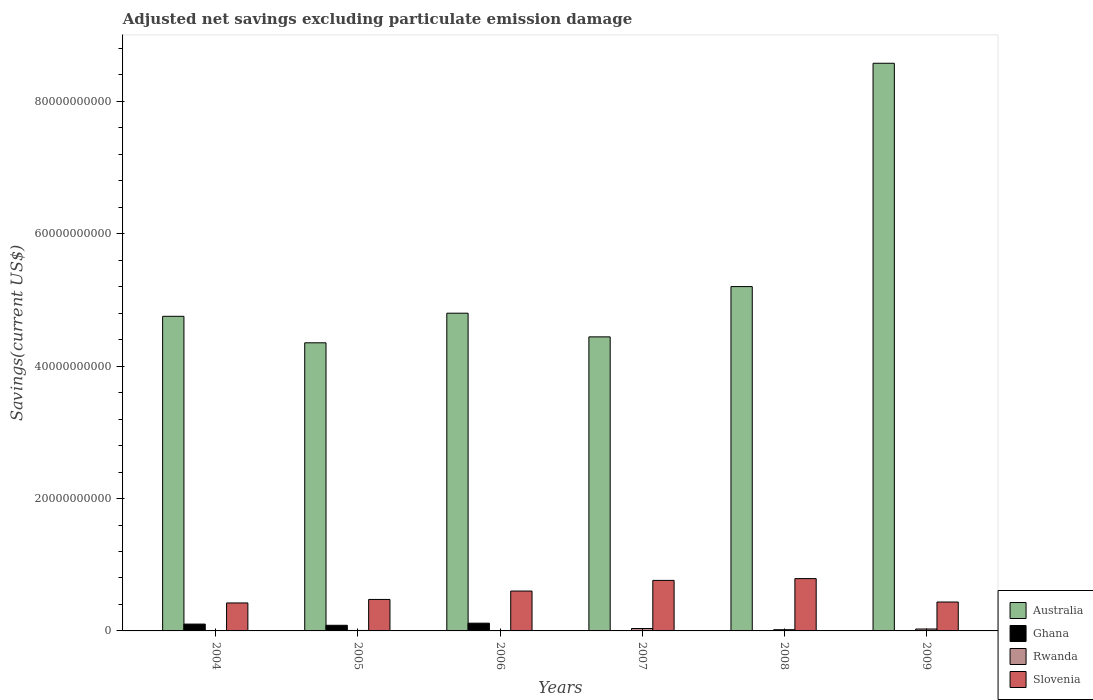How many groups of bars are there?
Ensure brevity in your answer.  6. Are the number of bars per tick equal to the number of legend labels?
Keep it short and to the point. No. Are the number of bars on each tick of the X-axis equal?
Your answer should be very brief. No. In how many cases, is the number of bars for a given year not equal to the number of legend labels?
Give a very brief answer. 2. What is the adjusted net savings in Rwanda in 2005?
Your answer should be very brief. 6.94e+07. Across all years, what is the maximum adjusted net savings in Australia?
Give a very brief answer. 8.58e+1. Across all years, what is the minimum adjusted net savings in Australia?
Ensure brevity in your answer.  4.35e+1. What is the total adjusted net savings in Slovenia in the graph?
Give a very brief answer. 3.49e+1. What is the difference between the adjusted net savings in Ghana in 2004 and that in 2005?
Your answer should be very brief. 1.82e+08. What is the difference between the adjusted net savings in Slovenia in 2009 and the adjusted net savings in Ghana in 2006?
Your response must be concise. 3.20e+09. What is the average adjusted net savings in Slovenia per year?
Ensure brevity in your answer.  5.82e+09. In the year 2007, what is the difference between the adjusted net savings in Rwanda and adjusted net savings in Slovenia?
Give a very brief answer. -7.27e+09. What is the ratio of the adjusted net savings in Ghana in 2005 to that in 2009?
Provide a short and direct response. 362.39. Is the adjusted net savings in Slovenia in 2007 less than that in 2008?
Ensure brevity in your answer.  Yes. Is the difference between the adjusted net savings in Rwanda in 2006 and 2007 greater than the difference between the adjusted net savings in Slovenia in 2006 and 2007?
Provide a short and direct response. Yes. What is the difference between the highest and the second highest adjusted net savings in Ghana?
Offer a very short reply. 1.38e+08. What is the difference between the highest and the lowest adjusted net savings in Australia?
Make the answer very short. 4.22e+1. Is it the case that in every year, the sum of the adjusted net savings in Australia and adjusted net savings in Rwanda is greater than the adjusted net savings in Slovenia?
Your answer should be very brief. Yes. Are the values on the major ticks of Y-axis written in scientific E-notation?
Your response must be concise. No. Does the graph contain grids?
Provide a short and direct response. No. Where does the legend appear in the graph?
Your response must be concise. Bottom right. How are the legend labels stacked?
Offer a terse response. Vertical. What is the title of the graph?
Provide a short and direct response. Adjusted net savings excluding particulate emission damage. What is the label or title of the X-axis?
Keep it short and to the point. Years. What is the label or title of the Y-axis?
Provide a short and direct response. Savings(current US$). What is the Savings(current US$) of Australia in 2004?
Keep it short and to the point. 4.75e+1. What is the Savings(current US$) of Ghana in 2004?
Provide a short and direct response. 1.03e+09. What is the Savings(current US$) of Rwanda in 2004?
Ensure brevity in your answer.  2.06e+07. What is the Savings(current US$) in Slovenia in 2004?
Your response must be concise. 4.23e+09. What is the Savings(current US$) in Australia in 2005?
Ensure brevity in your answer.  4.35e+1. What is the Savings(current US$) of Ghana in 2005?
Your response must be concise. 8.50e+08. What is the Savings(current US$) of Rwanda in 2005?
Ensure brevity in your answer.  6.94e+07. What is the Savings(current US$) of Slovenia in 2005?
Provide a succinct answer. 4.76e+09. What is the Savings(current US$) in Australia in 2006?
Your answer should be very brief. 4.80e+1. What is the Savings(current US$) of Ghana in 2006?
Your response must be concise. 1.17e+09. What is the Savings(current US$) of Rwanda in 2006?
Give a very brief answer. 5.25e+07. What is the Savings(current US$) in Slovenia in 2006?
Your answer should be compact. 6.02e+09. What is the Savings(current US$) in Australia in 2007?
Offer a very short reply. 4.44e+1. What is the Savings(current US$) of Rwanda in 2007?
Offer a terse response. 3.66e+08. What is the Savings(current US$) in Slovenia in 2007?
Your answer should be compact. 7.63e+09. What is the Savings(current US$) of Australia in 2008?
Your answer should be very brief. 5.20e+1. What is the Savings(current US$) of Ghana in 2008?
Ensure brevity in your answer.  0. What is the Savings(current US$) of Rwanda in 2008?
Your answer should be very brief. 1.84e+08. What is the Savings(current US$) of Slovenia in 2008?
Ensure brevity in your answer.  7.90e+09. What is the Savings(current US$) in Australia in 2009?
Give a very brief answer. 8.58e+1. What is the Savings(current US$) of Ghana in 2009?
Give a very brief answer. 2.35e+06. What is the Savings(current US$) of Rwanda in 2009?
Make the answer very short. 2.89e+08. What is the Savings(current US$) of Slovenia in 2009?
Your answer should be very brief. 4.37e+09. Across all years, what is the maximum Savings(current US$) in Australia?
Keep it short and to the point. 8.58e+1. Across all years, what is the maximum Savings(current US$) in Ghana?
Your answer should be very brief. 1.17e+09. Across all years, what is the maximum Savings(current US$) in Rwanda?
Offer a very short reply. 3.66e+08. Across all years, what is the maximum Savings(current US$) in Slovenia?
Keep it short and to the point. 7.90e+09. Across all years, what is the minimum Savings(current US$) of Australia?
Offer a terse response. 4.35e+1. Across all years, what is the minimum Savings(current US$) in Ghana?
Keep it short and to the point. 0. Across all years, what is the minimum Savings(current US$) in Rwanda?
Give a very brief answer. 2.06e+07. Across all years, what is the minimum Savings(current US$) of Slovenia?
Ensure brevity in your answer.  4.23e+09. What is the total Savings(current US$) in Australia in the graph?
Make the answer very short. 3.21e+11. What is the total Savings(current US$) of Ghana in the graph?
Your answer should be compact. 3.05e+09. What is the total Savings(current US$) in Rwanda in the graph?
Ensure brevity in your answer.  9.81e+08. What is the total Savings(current US$) in Slovenia in the graph?
Give a very brief answer. 3.49e+1. What is the difference between the Savings(current US$) of Australia in 2004 and that in 2005?
Your response must be concise. 4.00e+09. What is the difference between the Savings(current US$) in Ghana in 2004 and that in 2005?
Ensure brevity in your answer.  1.82e+08. What is the difference between the Savings(current US$) of Rwanda in 2004 and that in 2005?
Your answer should be compact. -4.88e+07. What is the difference between the Savings(current US$) of Slovenia in 2004 and that in 2005?
Ensure brevity in your answer.  -5.29e+08. What is the difference between the Savings(current US$) in Australia in 2004 and that in 2006?
Ensure brevity in your answer.  -4.69e+08. What is the difference between the Savings(current US$) of Ghana in 2004 and that in 2006?
Offer a very short reply. -1.38e+08. What is the difference between the Savings(current US$) in Rwanda in 2004 and that in 2006?
Provide a succinct answer. -3.19e+07. What is the difference between the Savings(current US$) in Slovenia in 2004 and that in 2006?
Offer a terse response. -1.80e+09. What is the difference between the Savings(current US$) of Australia in 2004 and that in 2007?
Your response must be concise. 3.11e+09. What is the difference between the Savings(current US$) in Rwanda in 2004 and that in 2007?
Offer a very short reply. -3.45e+08. What is the difference between the Savings(current US$) of Slovenia in 2004 and that in 2007?
Provide a succinct answer. -3.41e+09. What is the difference between the Savings(current US$) of Australia in 2004 and that in 2008?
Offer a very short reply. -4.49e+09. What is the difference between the Savings(current US$) of Rwanda in 2004 and that in 2008?
Offer a very short reply. -1.63e+08. What is the difference between the Savings(current US$) in Slovenia in 2004 and that in 2008?
Give a very brief answer. -3.68e+09. What is the difference between the Savings(current US$) in Australia in 2004 and that in 2009?
Offer a terse response. -3.82e+1. What is the difference between the Savings(current US$) of Ghana in 2004 and that in 2009?
Make the answer very short. 1.03e+09. What is the difference between the Savings(current US$) in Rwanda in 2004 and that in 2009?
Make the answer very short. -2.68e+08. What is the difference between the Savings(current US$) in Slovenia in 2004 and that in 2009?
Your answer should be compact. -1.42e+08. What is the difference between the Savings(current US$) in Australia in 2005 and that in 2006?
Offer a very short reply. -4.47e+09. What is the difference between the Savings(current US$) in Ghana in 2005 and that in 2006?
Offer a very short reply. -3.20e+08. What is the difference between the Savings(current US$) in Rwanda in 2005 and that in 2006?
Provide a succinct answer. 1.68e+07. What is the difference between the Savings(current US$) of Slovenia in 2005 and that in 2006?
Offer a terse response. -1.27e+09. What is the difference between the Savings(current US$) in Australia in 2005 and that in 2007?
Your response must be concise. -8.97e+08. What is the difference between the Savings(current US$) in Rwanda in 2005 and that in 2007?
Offer a very short reply. -2.96e+08. What is the difference between the Savings(current US$) of Slovenia in 2005 and that in 2007?
Your answer should be very brief. -2.88e+09. What is the difference between the Savings(current US$) of Australia in 2005 and that in 2008?
Offer a very short reply. -8.49e+09. What is the difference between the Savings(current US$) in Rwanda in 2005 and that in 2008?
Provide a short and direct response. -1.15e+08. What is the difference between the Savings(current US$) in Slovenia in 2005 and that in 2008?
Offer a terse response. -3.15e+09. What is the difference between the Savings(current US$) in Australia in 2005 and that in 2009?
Provide a short and direct response. -4.22e+1. What is the difference between the Savings(current US$) of Ghana in 2005 and that in 2009?
Give a very brief answer. 8.48e+08. What is the difference between the Savings(current US$) in Rwanda in 2005 and that in 2009?
Provide a succinct answer. -2.19e+08. What is the difference between the Savings(current US$) of Slovenia in 2005 and that in 2009?
Offer a very short reply. 3.87e+08. What is the difference between the Savings(current US$) of Australia in 2006 and that in 2007?
Give a very brief answer. 3.58e+09. What is the difference between the Savings(current US$) in Rwanda in 2006 and that in 2007?
Offer a terse response. -3.13e+08. What is the difference between the Savings(current US$) in Slovenia in 2006 and that in 2007?
Your response must be concise. -1.61e+09. What is the difference between the Savings(current US$) of Australia in 2006 and that in 2008?
Provide a short and direct response. -4.02e+09. What is the difference between the Savings(current US$) of Rwanda in 2006 and that in 2008?
Give a very brief answer. -1.32e+08. What is the difference between the Savings(current US$) in Slovenia in 2006 and that in 2008?
Provide a short and direct response. -1.88e+09. What is the difference between the Savings(current US$) in Australia in 2006 and that in 2009?
Provide a succinct answer. -3.78e+1. What is the difference between the Savings(current US$) in Ghana in 2006 and that in 2009?
Ensure brevity in your answer.  1.17e+09. What is the difference between the Savings(current US$) in Rwanda in 2006 and that in 2009?
Your answer should be compact. -2.36e+08. What is the difference between the Savings(current US$) in Slovenia in 2006 and that in 2009?
Offer a very short reply. 1.65e+09. What is the difference between the Savings(current US$) in Australia in 2007 and that in 2008?
Offer a very short reply. -7.60e+09. What is the difference between the Savings(current US$) of Rwanda in 2007 and that in 2008?
Make the answer very short. 1.82e+08. What is the difference between the Savings(current US$) in Slovenia in 2007 and that in 2008?
Offer a very short reply. -2.70e+08. What is the difference between the Savings(current US$) in Australia in 2007 and that in 2009?
Your answer should be very brief. -4.13e+1. What is the difference between the Savings(current US$) in Rwanda in 2007 and that in 2009?
Your answer should be very brief. 7.70e+07. What is the difference between the Savings(current US$) in Slovenia in 2007 and that in 2009?
Give a very brief answer. 3.26e+09. What is the difference between the Savings(current US$) in Australia in 2008 and that in 2009?
Your response must be concise. -3.37e+1. What is the difference between the Savings(current US$) in Rwanda in 2008 and that in 2009?
Your response must be concise. -1.05e+08. What is the difference between the Savings(current US$) in Slovenia in 2008 and that in 2009?
Your response must be concise. 3.53e+09. What is the difference between the Savings(current US$) of Australia in 2004 and the Savings(current US$) of Ghana in 2005?
Your response must be concise. 4.67e+1. What is the difference between the Savings(current US$) of Australia in 2004 and the Savings(current US$) of Rwanda in 2005?
Your response must be concise. 4.75e+1. What is the difference between the Savings(current US$) in Australia in 2004 and the Savings(current US$) in Slovenia in 2005?
Provide a short and direct response. 4.28e+1. What is the difference between the Savings(current US$) in Ghana in 2004 and the Savings(current US$) in Rwanda in 2005?
Provide a short and direct response. 9.62e+08. What is the difference between the Savings(current US$) of Ghana in 2004 and the Savings(current US$) of Slovenia in 2005?
Give a very brief answer. -3.72e+09. What is the difference between the Savings(current US$) of Rwanda in 2004 and the Savings(current US$) of Slovenia in 2005?
Offer a very short reply. -4.74e+09. What is the difference between the Savings(current US$) of Australia in 2004 and the Savings(current US$) of Ghana in 2006?
Your response must be concise. 4.64e+1. What is the difference between the Savings(current US$) of Australia in 2004 and the Savings(current US$) of Rwanda in 2006?
Your answer should be compact. 4.75e+1. What is the difference between the Savings(current US$) of Australia in 2004 and the Savings(current US$) of Slovenia in 2006?
Offer a very short reply. 4.15e+1. What is the difference between the Savings(current US$) in Ghana in 2004 and the Savings(current US$) in Rwanda in 2006?
Give a very brief answer. 9.79e+08. What is the difference between the Savings(current US$) in Ghana in 2004 and the Savings(current US$) in Slovenia in 2006?
Your response must be concise. -4.99e+09. What is the difference between the Savings(current US$) in Rwanda in 2004 and the Savings(current US$) in Slovenia in 2006?
Keep it short and to the point. -6.00e+09. What is the difference between the Savings(current US$) in Australia in 2004 and the Savings(current US$) in Rwanda in 2007?
Make the answer very short. 4.72e+1. What is the difference between the Savings(current US$) in Australia in 2004 and the Savings(current US$) in Slovenia in 2007?
Ensure brevity in your answer.  3.99e+1. What is the difference between the Savings(current US$) of Ghana in 2004 and the Savings(current US$) of Rwanda in 2007?
Your answer should be compact. 6.66e+08. What is the difference between the Savings(current US$) in Ghana in 2004 and the Savings(current US$) in Slovenia in 2007?
Provide a short and direct response. -6.60e+09. What is the difference between the Savings(current US$) of Rwanda in 2004 and the Savings(current US$) of Slovenia in 2007?
Give a very brief answer. -7.61e+09. What is the difference between the Savings(current US$) of Australia in 2004 and the Savings(current US$) of Rwanda in 2008?
Offer a terse response. 4.73e+1. What is the difference between the Savings(current US$) in Australia in 2004 and the Savings(current US$) in Slovenia in 2008?
Give a very brief answer. 3.96e+1. What is the difference between the Savings(current US$) of Ghana in 2004 and the Savings(current US$) of Rwanda in 2008?
Offer a very short reply. 8.48e+08. What is the difference between the Savings(current US$) of Ghana in 2004 and the Savings(current US$) of Slovenia in 2008?
Keep it short and to the point. -6.87e+09. What is the difference between the Savings(current US$) of Rwanda in 2004 and the Savings(current US$) of Slovenia in 2008?
Your answer should be very brief. -7.88e+09. What is the difference between the Savings(current US$) of Australia in 2004 and the Savings(current US$) of Ghana in 2009?
Ensure brevity in your answer.  4.75e+1. What is the difference between the Savings(current US$) in Australia in 2004 and the Savings(current US$) in Rwanda in 2009?
Provide a succinct answer. 4.72e+1. What is the difference between the Savings(current US$) in Australia in 2004 and the Savings(current US$) in Slovenia in 2009?
Give a very brief answer. 4.32e+1. What is the difference between the Savings(current US$) in Ghana in 2004 and the Savings(current US$) in Rwanda in 2009?
Offer a terse response. 7.43e+08. What is the difference between the Savings(current US$) in Ghana in 2004 and the Savings(current US$) in Slovenia in 2009?
Ensure brevity in your answer.  -3.34e+09. What is the difference between the Savings(current US$) of Rwanda in 2004 and the Savings(current US$) of Slovenia in 2009?
Keep it short and to the point. -4.35e+09. What is the difference between the Savings(current US$) of Australia in 2005 and the Savings(current US$) of Ghana in 2006?
Your answer should be compact. 4.24e+1. What is the difference between the Savings(current US$) of Australia in 2005 and the Savings(current US$) of Rwanda in 2006?
Give a very brief answer. 4.35e+1. What is the difference between the Savings(current US$) in Australia in 2005 and the Savings(current US$) in Slovenia in 2006?
Offer a terse response. 3.75e+1. What is the difference between the Savings(current US$) of Ghana in 2005 and the Savings(current US$) of Rwanda in 2006?
Give a very brief answer. 7.97e+08. What is the difference between the Savings(current US$) of Ghana in 2005 and the Savings(current US$) of Slovenia in 2006?
Offer a very short reply. -5.17e+09. What is the difference between the Savings(current US$) of Rwanda in 2005 and the Savings(current US$) of Slovenia in 2006?
Offer a very short reply. -5.95e+09. What is the difference between the Savings(current US$) in Australia in 2005 and the Savings(current US$) in Rwanda in 2007?
Offer a very short reply. 4.32e+1. What is the difference between the Savings(current US$) in Australia in 2005 and the Savings(current US$) in Slovenia in 2007?
Give a very brief answer. 3.59e+1. What is the difference between the Savings(current US$) of Ghana in 2005 and the Savings(current US$) of Rwanda in 2007?
Offer a very short reply. 4.84e+08. What is the difference between the Savings(current US$) in Ghana in 2005 and the Savings(current US$) in Slovenia in 2007?
Give a very brief answer. -6.78e+09. What is the difference between the Savings(current US$) in Rwanda in 2005 and the Savings(current US$) in Slovenia in 2007?
Offer a terse response. -7.56e+09. What is the difference between the Savings(current US$) in Australia in 2005 and the Savings(current US$) in Rwanda in 2008?
Provide a short and direct response. 4.33e+1. What is the difference between the Savings(current US$) in Australia in 2005 and the Savings(current US$) in Slovenia in 2008?
Provide a short and direct response. 3.56e+1. What is the difference between the Savings(current US$) of Ghana in 2005 and the Savings(current US$) of Rwanda in 2008?
Make the answer very short. 6.66e+08. What is the difference between the Savings(current US$) in Ghana in 2005 and the Savings(current US$) in Slovenia in 2008?
Provide a succinct answer. -7.05e+09. What is the difference between the Savings(current US$) in Rwanda in 2005 and the Savings(current US$) in Slovenia in 2008?
Your response must be concise. -7.83e+09. What is the difference between the Savings(current US$) in Australia in 2005 and the Savings(current US$) in Ghana in 2009?
Give a very brief answer. 4.35e+1. What is the difference between the Savings(current US$) of Australia in 2005 and the Savings(current US$) of Rwanda in 2009?
Your response must be concise. 4.32e+1. What is the difference between the Savings(current US$) of Australia in 2005 and the Savings(current US$) of Slovenia in 2009?
Provide a short and direct response. 3.92e+1. What is the difference between the Savings(current US$) in Ghana in 2005 and the Savings(current US$) in Rwanda in 2009?
Make the answer very short. 5.61e+08. What is the difference between the Savings(current US$) of Ghana in 2005 and the Savings(current US$) of Slovenia in 2009?
Ensure brevity in your answer.  -3.52e+09. What is the difference between the Savings(current US$) of Rwanda in 2005 and the Savings(current US$) of Slovenia in 2009?
Your answer should be compact. -4.30e+09. What is the difference between the Savings(current US$) in Australia in 2006 and the Savings(current US$) in Rwanda in 2007?
Keep it short and to the point. 4.76e+1. What is the difference between the Savings(current US$) of Australia in 2006 and the Savings(current US$) of Slovenia in 2007?
Ensure brevity in your answer.  4.04e+1. What is the difference between the Savings(current US$) in Ghana in 2006 and the Savings(current US$) in Rwanda in 2007?
Make the answer very short. 8.04e+08. What is the difference between the Savings(current US$) of Ghana in 2006 and the Savings(current US$) of Slovenia in 2007?
Ensure brevity in your answer.  -6.46e+09. What is the difference between the Savings(current US$) in Rwanda in 2006 and the Savings(current US$) in Slovenia in 2007?
Offer a very short reply. -7.58e+09. What is the difference between the Savings(current US$) in Australia in 2006 and the Savings(current US$) in Rwanda in 2008?
Make the answer very short. 4.78e+1. What is the difference between the Savings(current US$) in Australia in 2006 and the Savings(current US$) in Slovenia in 2008?
Your response must be concise. 4.01e+1. What is the difference between the Savings(current US$) of Ghana in 2006 and the Savings(current US$) of Rwanda in 2008?
Make the answer very short. 9.86e+08. What is the difference between the Savings(current US$) of Ghana in 2006 and the Savings(current US$) of Slovenia in 2008?
Your answer should be very brief. -6.73e+09. What is the difference between the Savings(current US$) of Rwanda in 2006 and the Savings(current US$) of Slovenia in 2008?
Make the answer very short. -7.85e+09. What is the difference between the Savings(current US$) in Australia in 2006 and the Savings(current US$) in Ghana in 2009?
Your answer should be very brief. 4.80e+1. What is the difference between the Savings(current US$) in Australia in 2006 and the Savings(current US$) in Rwanda in 2009?
Your response must be concise. 4.77e+1. What is the difference between the Savings(current US$) of Australia in 2006 and the Savings(current US$) of Slovenia in 2009?
Provide a short and direct response. 4.36e+1. What is the difference between the Savings(current US$) of Ghana in 2006 and the Savings(current US$) of Rwanda in 2009?
Your response must be concise. 8.81e+08. What is the difference between the Savings(current US$) in Ghana in 2006 and the Savings(current US$) in Slovenia in 2009?
Offer a terse response. -3.20e+09. What is the difference between the Savings(current US$) in Rwanda in 2006 and the Savings(current US$) in Slovenia in 2009?
Provide a succinct answer. -4.32e+09. What is the difference between the Savings(current US$) of Australia in 2007 and the Savings(current US$) of Rwanda in 2008?
Provide a succinct answer. 4.42e+1. What is the difference between the Savings(current US$) of Australia in 2007 and the Savings(current US$) of Slovenia in 2008?
Ensure brevity in your answer.  3.65e+1. What is the difference between the Savings(current US$) of Rwanda in 2007 and the Savings(current US$) of Slovenia in 2008?
Your response must be concise. -7.54e+09. What is the difference between the Savings(current US$) of Australia in 2007 and the Savings(current US$) of Ghana in 2009?
Make the answer very short. 4.44e+1. What is the difference between the Savings(current US$) in Australia in 2007 and the Savings(current US$) in Rwanda in 2009?
Give a very brief answer. 4.41e+1. What is the difference between the Savings(current US$) of Australia in 2007 and the Savings(current US$) of Slovenia in 2009?
Your response must be concise. 4.01e+1. What is the difference between the Savings(current US$) in Rwanda in 2007 and the Savings(current US$) in Slovenia in 2009?
Offer a very short reply. -4.00e+09. What is the difference between the Savings(current US$) in Australia in 2008 and the Savings(current US$) in Ghana in 2009?
Offer a terse response. 5.20e+1. What is the difference between the Savings(current US$) in Australia in 2008 and the Savings(current US$) in Rwanda in 2009?
Provide a short and direct response. 5.17e+1. What is the difference between the Savings(current US$) of Australia in 2008 and the Savings(current US$) of Slovenia in 2009?
Provide a succinct answer. 4.77e+1. What is the difference between the Savings(current US$) of Rwanda in 2008 and the Savings(current US$) of Slovenia in 2009?
Ensure brevity in your answer.  -4.19e+09. What is the average Savings(current US$) of Australia per year?
Your answer should be compact. 5.35e+1. What is the average Savings(current US$) of Ghana per year?
Offer a very short reply. 5.09e+08. What is the average Savings(current US$) in Rwanda per year?
Ensure brevity in your answer.  1.64e+08. What is the average Savings(current US$) in Slovenia per year?
Your answer should be very brief. 5.82e+09. In the year 2004, what is the difference between the Savings(current US$) in Australia and Savings(current US$) in Ghana?
Make the answer very short. 4.65e+1. In the year 2004, what is the difference between the Savings(current US$) in Australia and Savings(current US$) in Rwanda?
Provide a short and direct response. 4.75e+1. In the year 2004, what is the difference between the Savings(current US$) in Australia and Savings(current US$) in Slovenia?
Provide a succinct answer. 4.33e+1. In the year 2004, what is the difference between the Savings(current US$) in Ghana and Savings(current US$) in Rwanda?
Give a very brief answer. 1.01e+09. In the year 2004, what is the difference between the Savings(current US$) in Ghana and Savings(current US$) in Slovenia?
Make the answer very short. -3.20e+09. In the year 2004, what is the difference between the Savings(current US$) in Rwanda and Savings(current US$) in Slovenia?
Make the answer very short. -4.21e+09. In the year 2005, what is the difference between the Savings(current US$) of Australia and Savings(current US$) of Ghana?
Your answer should be very brief. 4.27e+1. In the year 2005, what is the difference between the Savings(current US$) in Australia and Savings(current US$) in Rwanda?
Provide a succinct answer. 4.35e+1. In the year 2005, what is the difference between the Savings(current US$) in Australia and Savings(current US$) in Slovenia?
Make the answer very short. 3.88e+1. In the year 2005, what is the difference between the Savings(current US$) in Ghana and Savings(current US$) in Rwanda?
Ensure brevity in your answer.  7.81e+08. In the year 2005, what is the difference between the Savings(current US$) in Ghana and Savings(current US$) in Slovenia?
Keep it short and to the point. -3.91e+09. In the year 2005, what is the difference between the Savings(current US$) in Rwanda and Savings(current US$) in Slovenia?
Ensure brevity in your answer.  -4.69e+09. In the year 2006, what is the difference between the Savings(current US$) in Australia and Savings(current US$) in Ghana?
Your answer should be compact. 4.68e+1. In the year 2006, what is the difference between the Savings(current US$) of Australia and Savings(current US$) of Rwanda?
Keep it short and to the point. 4.79e+1. In the year 2006, what is the difference between the Savings(current US$) of Australia and Savings(current US$) of Slovenia?
Make the answer very short. 4.20e+1. In the year 2006, what is the difference between the Savings(current US$) in Ghana and Savings(current US$) in Rwanda?
Provide a succinct answer. 1.12e+09. In the year 2006, what is the difference between the Savings(current US$) of Ghana and Savings(current US$) of Slovenia?
Offer a very short reply. -4.85e+09. In the year 2006, what is the difference between the Savings(current US$) of Rwanda and Savings(current US$) of Slovenia?
Provide a short and direct response. -5.97e+09. In the year 2007, what is the difference between the Savings(current US$) of Australia and Savings(current US$) of Rwanda?
Offer a terse response. 4.41e+1. In the year 2007, what is the difference between the Savings(current US$) of Australia and Savings(current US$) of Slovenia?
Offer a very short reply. 3.68e+1. In the year 2007, what is the difference between the Savings(current US$) of Rwanda and Savings(current US$) of Slovenia?
Offer a very short reply. -7.27e+09. In the year 2008, what is the difference between the Savings(current US$) of Australia and Savings(current US$) of Rwanda?
Make the answer very short. 5.18e+1. In the year 2008, what is the difference between the Savings(current US$) of Australia and Savings(current US$) of Slovenia?
Provide a succinct answer. 4.41e+1. In the year 2008, what is the difference between the Savings(current US$) of Rwanda and Savings(current US$) of Slovenia?
Give a very brief answer. -7.72e+09. In the year 2009, what is the difference between the Savings(current US$) of Australia and Savings(current US$) of Ghana?
Provide a short and direct response. 8.58e+1. In the year 2009, what is the difference between the Savings(current US$) of Australia and Savings(current US$) of Rwanda?
Offer a terse response. 8.55e+1. In the year 2009, what is the difference between the Savings(current US$) in Australia and Savings(current US$) in Slovenia?
Your answer should be compact. 8.14e+1. In the year 2009, what is the difference between the Savings(current US$) of Ghana and Savings(current US$) of Rwanda?
Offer a terse response. -2.86e+08. In the year 2009, what is the difference between the Savings(current US$) of Ghana and Savings(current US$) of Slovenia?
Give a very brief answer. -4.37e+09. In the year 2009, what is the difference between the Savings(current US$) of Rwanda and Savings(current US$) of Slovenia?
Offer a very short reply. -4.08e+09. What is the ratio of the Savings(current US$) in Australia in 2004 to that in 2005?
Provide a short and direct response. 1.09. What is the ratio of the Savings(current US$) of Ghana in 2004 to that in 2005?
Keep it short and to the point. 1.21. What is the ratio of the Savings(current US$) in Rwanda in 2004 to that in 2005?
Your answer should be compact. 0.3. What is the ratio of the Savings(current US$) of Australia in 2004 to that in 2006?
Your response must be concise. 0.99. What is the ratio of the Savings(current US$) of Ghana in 2004 to that in 2006?
Give a very brief answer. 0.88. What is the ratio of the Savings(current US$) in Rwanda in 2004 to that in 2006?
Offer a terse response. 0.39. What is the ratio of the Savings(current US$) of Slovenia in 2004 to that in 2006?
Provide a short and direct response. 0.7. What is the ratio of the Savings(current US$) of Australia in 2004 to that in 2007?
Offer a very short reply. 1.07. What is the ratio of the Savings(current US$) in Rwanda in 2004 to that in 2007?
Give a very brief answer. 0.06. What is the ratio of the Savings(current US$) of Slovenia in 2004 to that in 2007?
Your response must be concise. 0.55. What is the ratio of the Savings(current US$) of Australia in 2004 to that in 2008?
Make the answer very short. 0.91. What is the ratio of the Savings(current US$) of Rwanda in 2004 to that in 2008?
Keep it short and to the point. 0.11. What is the ratio of the Savings(current US$) of Slovenia in 2004 to that in 2008?
Provide a short and direct response. 0.53. What is the ratio of the Savings(current US$) in Australia in 2004 to that in 2009?
Ensure brevity in your answer.  0.55. What is the ratio of the Savings(current US$) in Ghana in 2004 to that in 2009?
Offer a very short reply. 439.87. What is the ratio of the Savings(current US$) of Rwanda in 2004 to that in 2009?
Offer a very short reply. 0.07. What is the ratio of the Savings(current US$) of Slovenia in 2004 to that in 2009?
Your answer should be compact. 0.97. What is the ratio of the Savings(current US$) of Australia in 2005 to that in 2006?
Your answer should be very brief. 0.91. What is the ratio of the Savings(current US$) of Ghana in 2005 to that in 2006?
Make the answer very short. 0.73. What is the ratio of the Savings(current US$) in Rwanda in 2005 to that in 2006?
Give a very brief answer. 1.32. What is the ratio of the Savings(current US$) of Slovenia in 2005 to that in 2006?
Provide a short and direct response. 0.79. What is the ratio of the Savings(current US$) of Australia in 2005 to that in 2007?
Make the answer very short. 0.98. What is the ratio of the Savings(current US$) in Rwanda in 2005 to that in 2007?
Give a very brief answer. 0.19. What is the ratio of the Savings(current US$) in Slovenia in 2005 to that in 2007?
Give a very brief answer. 0.62. What is the ratio of the Savings(current US$) in Australia in 2005 to that in 2008?
Provide a short and direct response. 0.84. What is the ratio of the Savings(current US$) of Rwanda in 2005 to that in 2008?
Ensure brevity in your answer.  0.38. What is the ratio of the Savings(current US$) of Slovenia in 2005 to that in 2008?
Provide a succinct answer. 0.6. What is the ratio of the Savings(current US$) of Australia in 2005 to that in 2009?
Provide a succinct answer. 0.51. What is the ratio of the Savings(current US$) of Ghana in 2005 to that in 2009?
Your response must be concise. 362.39. What is the ratio of the Savings(current US$) in Rwanda in 2005 to that in 2009?
Your answer should be compact. 0.24. What is the ratio of the Savings(current US$) in Slovenia in 2005 to that in 2009?
Your answer should be very brief. 1.09. What is the ratio of the Savings(current US$) in Australia in 2006 to that in 2007?
Provide a short and direct response. 1.08. What is the ratio of the Savings(current US$) in Rwanda in 2006 to that in 2007?
Offer a very short reply. 0.14. What is the ratio of the Savings(current US$) of Slovenia in 2006 to that in 2007?
Make the answer very short. 0.79. What is the ratio of the Savings(current US$) of Australia in 2006 to that in 2008?
Provide a succinct answer. 0.92. What is the ratio of the Savings(current US$) of Rwanda in 2006 to that in 2008?
Provide a succinct answer. 0.29. What is the ratio of the Savings(current US$) in Slovenia in 2006 to that in 2008?
Provide a succinct answer. 0.76. What is the ratio of the Savings(current US$) in Australia in 2006 to that in 2009?
Make the answer very short. 0.56. What is the ratio of the Savings(current US$) of Ghana in 2006 to that in 2009?
Your answer should be compact. 498.74. What is the ratio of the Savings(current US$) in Rwanda in 2006 to that in 2009?
Provide a short and direct response. 0.18. What is the ratio of the Savings(current US$) of Slovenia in 2006 to that in 2009?
Offer a terse response. 1.38. What is the ratio of the Savings(current US$) of Australia in 2007 to that in 2008?
Provide a succinct answer. 0.85. What is the ratio of the Savings(current US$) in Rwanda in 2007 to that in 2008?
Your response must be concise. 1.99. What is the ratio of the Savings(current US$) of Slovenia in 2007 to that in 2008?
Make the answer very short. 0.97. What is the ratio of the Savings(current US$) of Australia in 2007 to that in 2009?
Your answer should be very brief. 0.52. What is the ratio of the Savings(current US$) in Rwanda in 2007 to that in 2009?
Your response must be concise. 1.27. What is the ratio of the Savings(current US$) of Slovenia in 2007 to that in 2009?
Offer a very short reply. 1.75. What is the ratio of the Savings(current US$) in Australia in 2008 to that in 2009?
Keep it short and to the point. 0.61. What is the ratio of the Savings(current US$) of Rwanda in 2008 to that in 2009?
Offer a terse response. 0.64. What is the ratio of the Savings(current US$) in Slovenia in 2008 to that in 2009?
Provide a succinct answer. 1.81. What is the difference between the highest and the second highest Savings(current US$) in Australia?
Your answer should be compact. 3.37e+1. What is the difference between the highest and the second highest Savings(current US$) of Ghana?
Offer a very short reply. 1.38e+08. What is the difference between the highest and the second highest Savings(current US$) in Rwanda?
Make the answer very short. 7.70e+07. What is the difference between the highest and the second highest Savings(current US$) of Slovenia?
Your response must be concise. 2.70e+08. What is the difference between the highest and the lowest Savings(current US$) of Australia?
Make the answer very short. 4.22e+1. What is the difference between the highest and the lowest Savings(current US$) in Ghana?
Your response must be concise. 1.17e+09. What is the difference between the highest and the lowest Savings(current US$) in Rwanda?
Provide a succinct answer. 3.45e+08. What is the difference between the highest and the lowest Savings(current US$) of Slovenia?
Your response must be concise. 3.68e+09. 